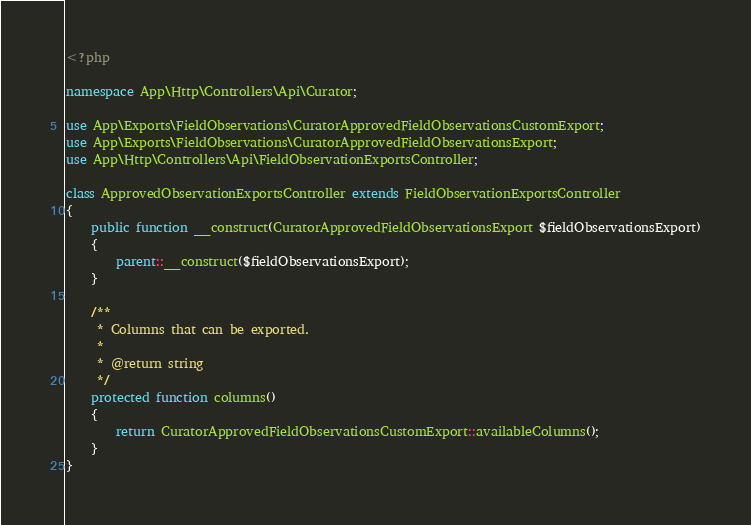<code> <loc_0><loc_0><loc_500><loc_500><_PHP_><?php

namespace App\Http\Controllers\Api\Curator;

use App\Exports\FieldObservations\CuratorApprovedFieldObservationsCustomExport;
use App\Exports\FieldObservations\CuratorApprovedFieldObservationsExport;
use App\Http\Controllers\Api\FieldObservationExportsController;

class ApprovedObservationExportsController extends FieldObservationExportsController
{
    public function __construct(CuratorApprovedFieldObservationsExport $fieldObservationsExport)
    {
        parent::__construct($fieldObservationsExport);
    }

    /**
     * Columns that can be exported.
     *
     * @return string
     */
    protected function columns()
    {
        return CuratorApprovedFieldObservationsCustomExport::availableColumns();
    }
}
</code> 